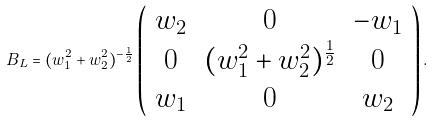Convert formula to latex. <formula><loc_0><loc_0><loc_500><loc_500>B _ { L } = ( w _ { 1 } ^ { 2 } + w _ { 2 } ^ { 2 } ) ^ { - \frac { 1 } { 2 } } \left ( \begin{array} { c c c } w _ { 2 } & 0 & - w _ { 1 } \\ 0 & ( w _ { 1 } ^ { 2 } + w _ { 2 } ^ { 2 } ) ^ { \frac { 1 } { 2 } } & 0 \\ w _ { 1 } & 0 & w _ { 2 } \end{array} \right ) .</formula> 